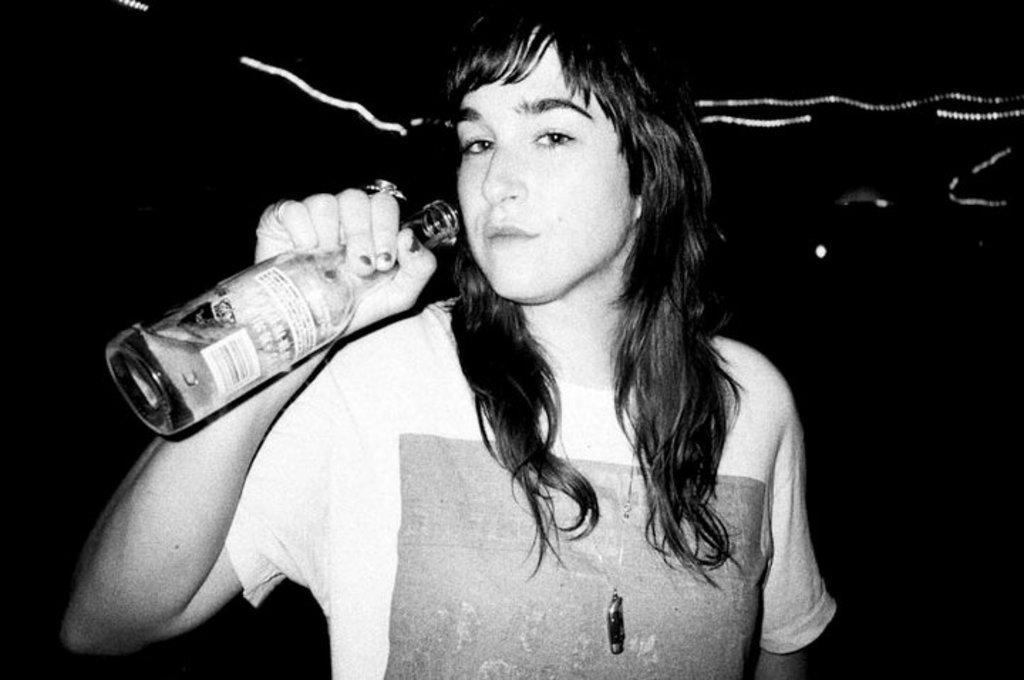What is the color scheme of the image? The image is black and white. Who is present in the image? There is a woman in the image. What is the woman doing in the image? The woman is standing in the image. What is the woman holding in her hand? The woman is holding a bottle in her hand. What type of robin can be seen sitting on the woman's shoulder in the image? There is no robin present in the image; it only features a woman standing and holding a bottle. What advice might the woman's mom give her in the image? There is no indication of the woman's mom being present in the image, so it is not possible to determine what advice she might give. 